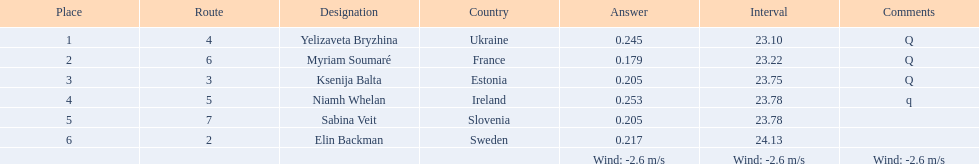What is the title of the athlete who ranked first in heat 1 of the women's 200-meter race? Yelizaveta Bryzhina. 